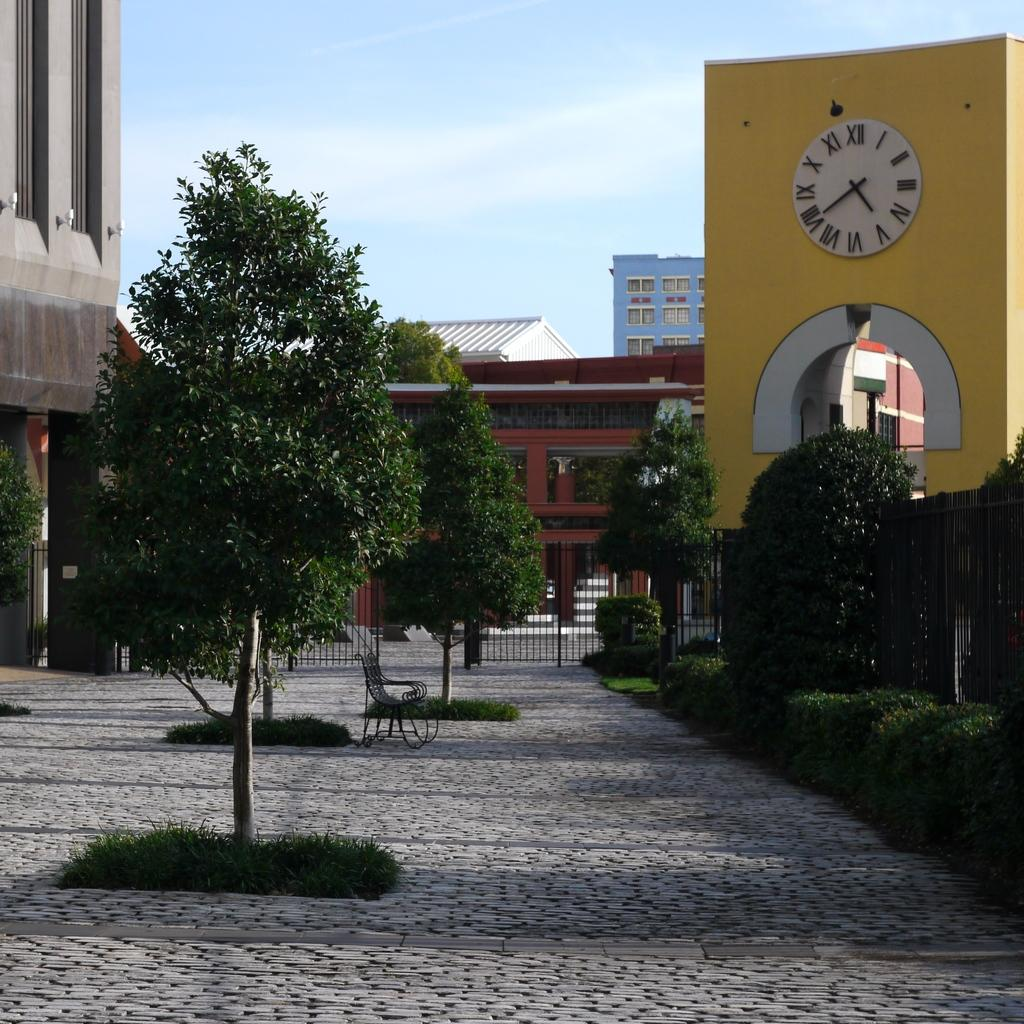What can be seen running through the image? There is a path in the image. What type of vegetation is present along the path? There are trees along the path. What structures can be seen in the distance? There are houses in the background of the image. What object is located on the right side of the image? There is a clock on the right side of the image. How does the school compare to the houses in the image? There is no school present in the image, so it cannot be compared to the houses. 